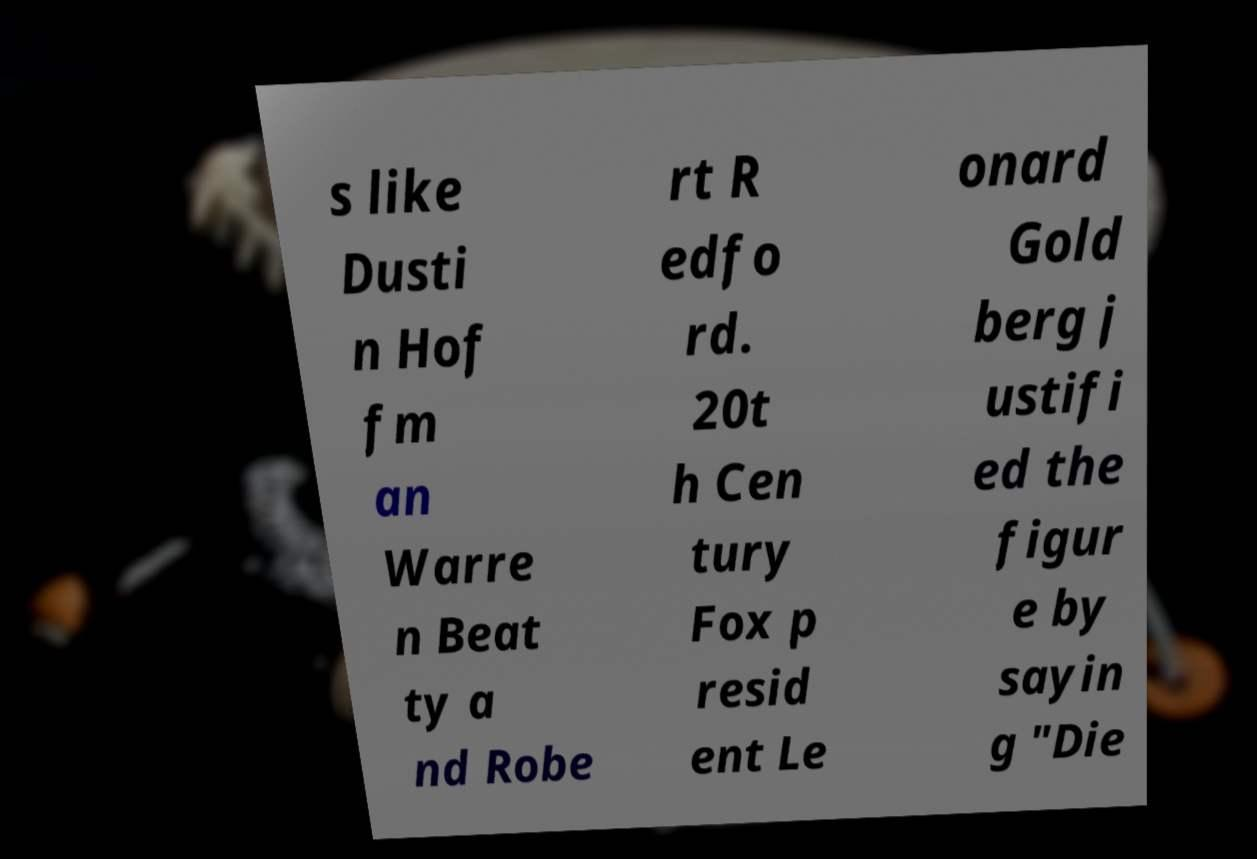Could you extract and type out the text from this image? s like Dusti n Hof fm an Warre n Beat ty a nd Robe rt R edfo rd. 20t h Cen tury Fox p resid ent Le onard Gold berg j ustifi ed the figur e by sayin g "Die 